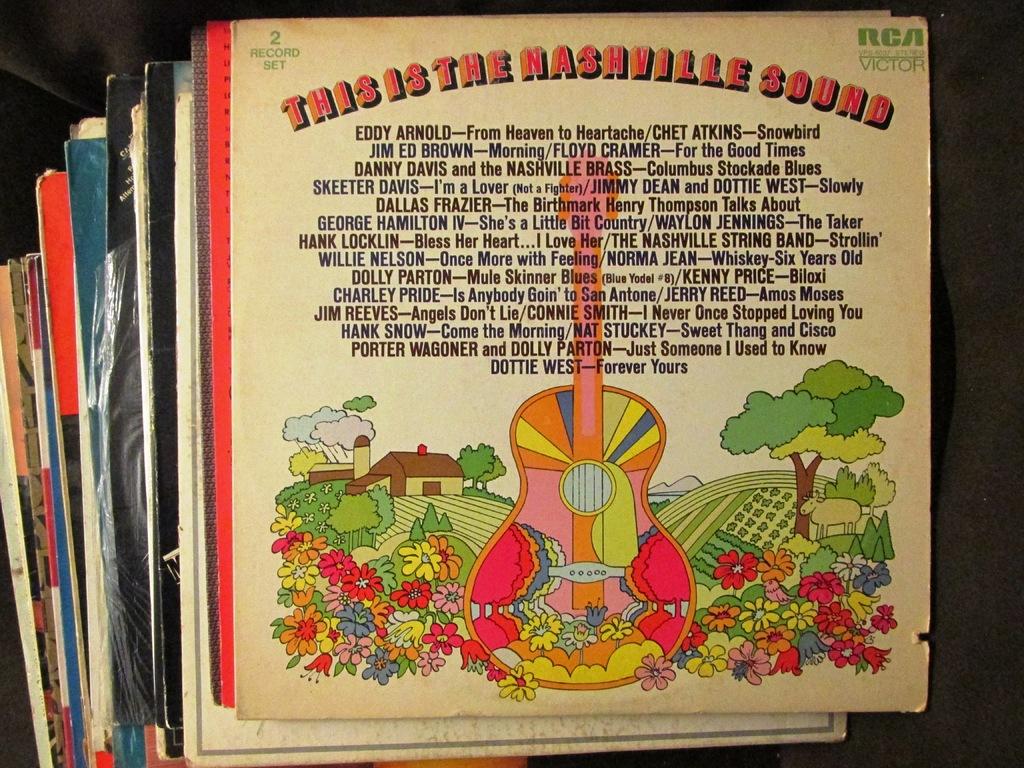What is the first word in the first line?
Provide a short and direct response. This. 